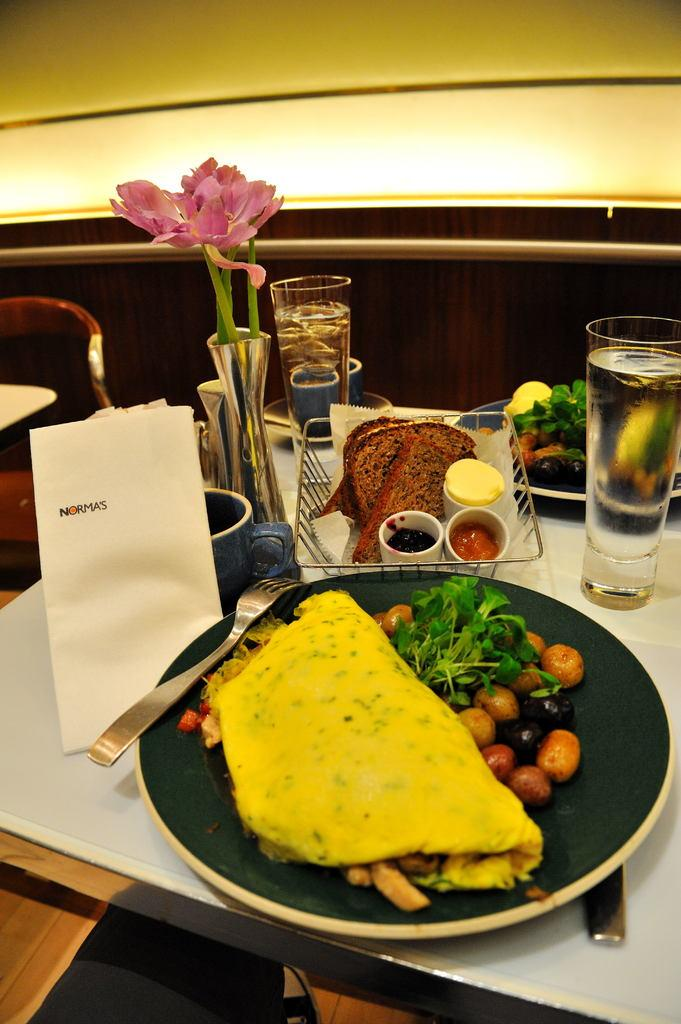What is present on the dining table in the image? There is food, a fork, a tissue, a flower vase, and a glass with water on the dining table. What utensil can be used for eating the food on the table? There is a fork on the dining table that can be used for eating the food. What is used for cleaning or wiping on the dining table? A tissue is present on the dining table for cleaning or wiping. What is used for holding flowers on the dining table? There is a flower vase on the dining table for holding flowers. What is used for drinking on the dining table? There is a glass with water on the dining table for drinking. What type of doctor is sitting at the dining table in the image? There is no doctor present in the image; it only shows objects on the dining table. How many oranges are on the dining table in the image? There are no oranges present in the image; it only shows food, a fork, a tissue, a flower vase, and a glass with water on the dining table. 